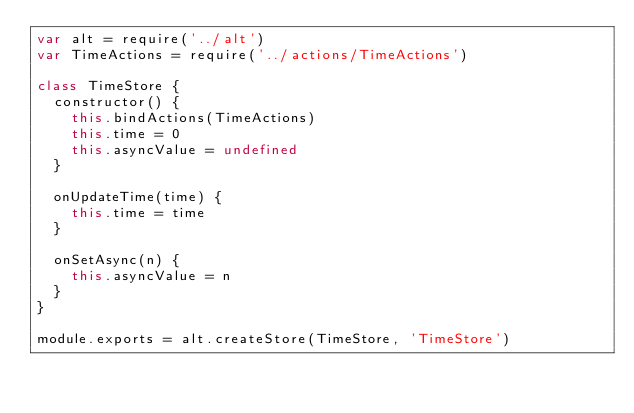Convert code to text. <code><loc_0><loc_0><loc_500><loc_500><_JavaScript_>var alt = require('../alt')
var TimeActions = require('../actions/TimeActions')

class TimeStore {
  constructor() {
    this.bindActions(TimeActions)
    this.time = 0
    this.asyncValue = undefined
  }

  onUpdateTime(time) {
    this.time = time
  }

  onSetAsync(n) {
    this.asyncValue = n
  }
}

module.exports = alt.createStore(TimeStore, 'TimeStore')
</code> 